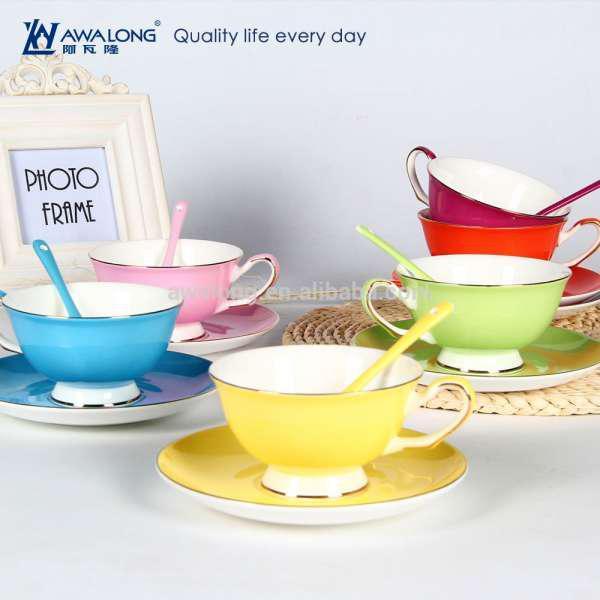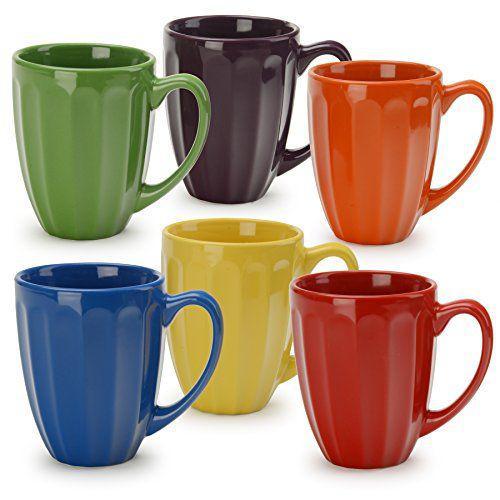The first image is the image on the left, the second image is the image on the right. Examine the images to the left and right. Is the description "At least 4 cups are each placed on top of matching colored plates." accurate? Answer yes or no. Yes. The first image is the image on the left, the second image is the image on the right. Given the left and right images, does the statement "In one image, the teacups are all the same color as the saucers they're sitting on." hold true? Answer yes or no. Yes. 